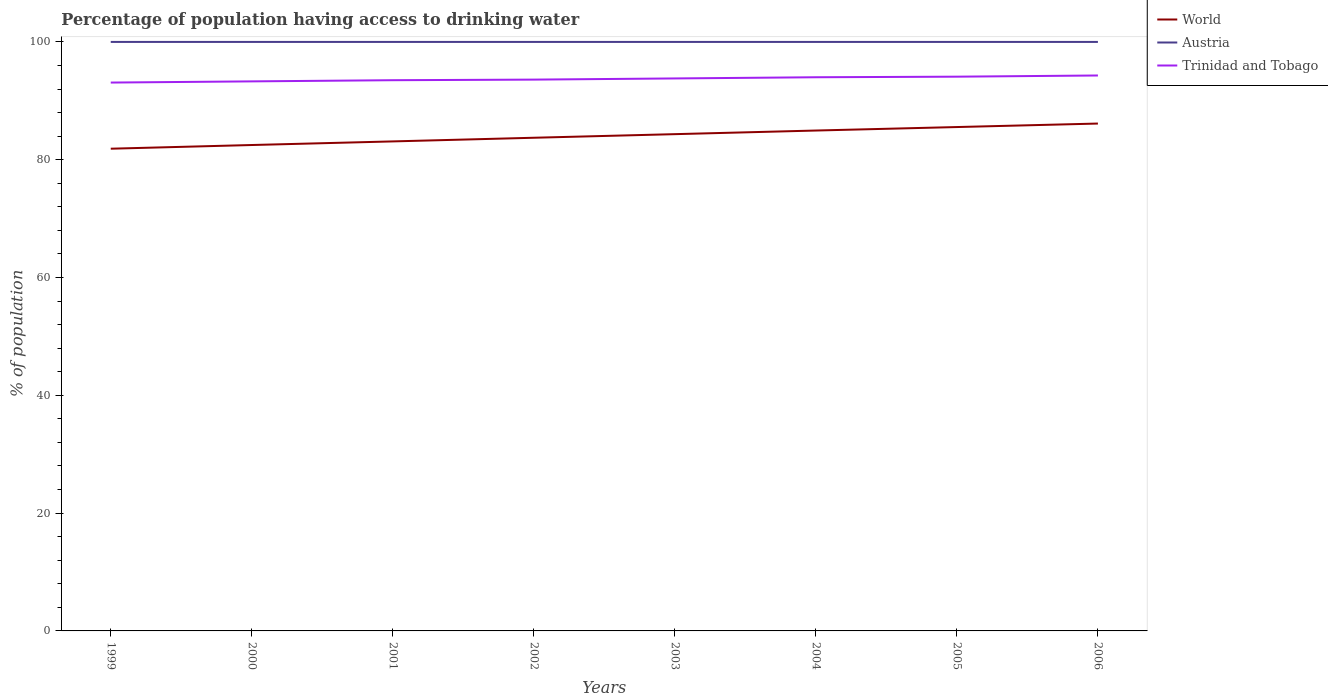How many different coloured lines are there?
Offer a very short reply. 3. Is the number of lines equal to the number of legend labels?
Ensure brevity in your answer.  Yes. Across all years, what is the maximum percentage of population having access to drinking water in Trinidad and Tobago?
Make the answer very short. 93.1. In which year was the percentage of population having access to drinking water in Trinidad and Tobago maximum?
Offer a very short reply. 1999. What is the total percentage of population having access to drinking water in World in the graph?
Your answer should be compact. -3.08. What is the difference between the highest and the second highest percentage of population having access to drinking water in Trinidad and Tobago?
Make the answer very short. 1.2. What is the difference between the highest and the lowest percentage of population having access to drinking water in World?
Provide a short and direct response. 4. How many years are there in the graph?
Offer a terse response. 8. Are the values on the major ticks of Y-axis written in scientific E-notation?
Make the answer very short. No. Does the graph contain grids?
Give a very brief answer. No. Where does the legend appear in the graph?
Your response must be concise. Top right. How are the legend labels stacked?
Your answer should be compact. Vertical. What is the title of the graph?
Offer a very short reply. Percentage of population having access to drinking water. Does "Belgium" appear as one of the legend labels in the graph?
Provide a succinct answer. No. What is the label or title of the X-axis?
Your answer should be very brief. Years. What is the label or title of the Y-axis?
Your answer should be very brief. % of population. What is the % of population of World in 1999?
Provide a succinct answer. 81.87. What is the % of population of Austria in 1999?
Keep it short and to the point. 100. What is the % of population of Trinidad and Tobago in 1999?
Your answer should be compact. 93.1. What is the % of population of World in 2000?
Ensure brevity in your answer.  82.5. What is the % of population in Trinidad and Tobago in 2000?
Give a very brief answer. 93.3. What is the % of population of World in 2001?
Offer a terse response. 83.11. What is the % of population of Austria in 2001?
Make the answer very short. 100. What is the % of population in Trinidad and Tobago in 2001?
Offer a very short reply. 93.5. What is the % of population in World in 2002?
Offer a very short reply. 83.73. What is the % of population of Austria in 2002?
Make the answer very short. 100. What is the % of population of Trinidad and Tobago in 2002?
Make the answer very short. 93.6. What is the % of population of World in 2003?
Your answer should be very brief. 84.34. What is the % of population in Austria in 2003?
Your response must be concise. 100. What is the % of population of Trinidad and Tobago in 2003?
Keep it short and to the point. 93.8. What is the % of population in World in 2004?
Provide a short and direct response. 84.95. What is the % of population in Austria in 2004?
Provide a succinct answer. 100. What is the % of population in Trinidad and Tobago in 2004?
Your answer should be very brief. 94. What is the % of population of World in 2005?
Keep it short and to the point. 85.55. What is the % of population of Trinidad and Tobago in 2005?
Ensure brevity in your answer.  94.1. What is the % of population in World in 2006?
Ensure brevity in your answer.  86.14. What is the % of population of Trinidad and Tobago in 2006?
Ensure brevity in your answer.  94.3. Across all years, what is the maximum % of population in World?
Make the answer very short. 86.14. Across all years, what is the maximum % of population in Trinidad and Tobago?
Keep it short and to the point. 94.3. Across all years, what is the minimum % of population in World?
Your answer should be compact. 81.87. Across all years, what is the minimum % of population in Trinidad and Tobago?
Your answer should be compact. 93.1. What is the total % of population of World in the graph?
Offer a very short reply. 672.19. What is the total % of population in Austria in the graph?
Your response must be concise. 800. What is the total % of population in Trinidad and Tobago in the graph?
Keep it short and to the point. 749.7. What is the difference between the % of population of World in 1999 and that in 2000?
Offer a terse response. -0.63. What is the difference between the % of population of Austria in 1999 and that in 2000?
Your answer should be compact. 0. What is the difference between the % of population of World in 1999 and that in 2001?
Ensure brevity in your answer.  -1.24. What is the difference between the % of population of World in 1999 and that in 2002?
Provide a succinct answer. -1.86. What is the difference between the % of population of Austria in 1999 and that in 2002?
Offer a terse response. 0. What is the difference between the % of population in Trinidad and Tobago in 1999 and that in 2002?
Offer a terse response. -0.5. What is the difference between the % of population in World in 1999 and that in 2003?
Provide a short and direct response. -2.47. What is the difference between the % of population of Austria in 1999 and that in 2003?
Give a very brief answer. 0. What is the difference between the % of population in World in 1999 and that in 2004?
Keep it short and to the point. -3.08. What is the difference between the % of population of Austria in 1999 and that in 2004?
Give a very brief answer. 0. What is the difference between the % of population in World in 1999 and that in 2005?
Provide a short and direct response. -3.68. What is the difference between the % of population of Austria in 1999 and that in 2005?
Provide a succinct answer. 0. What is the difference between the % of population in Trinidad and Tobago in 1999 and that in 2005?
Provide a short and direct response. -1. What is the difference between the % of population in World in 1999 and that in 2006?
Give a very brief answer. -4.27. What is the difference between the % of population in Austria in 1999 and that in 2006?
Provide a short and direct response. 0. What is the difference between the % of population of Trinidad and Tobago in 1999 and that in 2006?
Provide a succinct answer. -1.2. What is the difference between the % of population of World in 2000 and that in 2001?
Your answer should be very brief. -0.61. What is the difference between the % of population in Trinidad and Tobago in 2000 and that in 2001?
Your response must be concise. -0.2. What is the difference between the % of population of World in 2000 and that in 2002?
Offer a terse response. -1.23. What is the difference between the % of population of Austria in 2000 and that in 2002?
Your answer should be very brief. 0. What is the difference between the % of population in World in 2000 and that in 2003?
Provide a succinct answer. -1.84. What is the difference between the % of population of World in 2000 and that in 2004?
Ensure brevity in your answer.  -2.46. What is the difference between the % of population in Trinidad and Tobago in 2000 and that in 2004?
Keep it short and to the point. -0.7. What is the difference between the % of population of World in 2000 and that in 2005?
Offer a terse response. -3.05. What is the difference between the % of population of Trinidad and Tobago in 2000 and that in 2005?
Provide a short and direct response. -0.8. What is the difference between the % of population of World in 2000 and that in 2006?
Offer a terse response. -3.64. What is the difference between the % of population in Austria in 2000 and that in 2006?
Keep it short and to the point. 0. What is the difference between the % of population in World in 2001 and that in 2002?
Offer a terse response. -0.62. What is the difference between the % of population in Austria in 2001 and that in 2002?
Your answer should be very brief. 0. What is the difference between the % of population of World in 2001 and that in 2003?
Your response must be concise. -1.23. What is the difference between the % of population of Austria in 2001 and that in 2003?
Provide a short and direct response. 0. What is the difference between the % of population of Trinidad and Tobago in 2001 and that in 2003?
Offer a terse response. -0.3. What is the difference between the % of population in World in 2001 and that in 2004?
Make the answer very short. -1.85. What is the difference between the % of population in World in 2001 and that in 2005?
Provide a succinct answer. -2.44. What is the difference between the % of population of Trinidad and Tobago in 2001 and that in 2005?
Your response must be concise. -0.6. What is the difference between the % of population in World in 2001 and that in 2006?
Give a very brief answer. -3.03. What is the difference between the % of population in Trinidad and Tobago in 2001 and that in 2006?
Offer a terse response. -0.8. What is the difference between the % of population of World in 2002 and that in 2003?
Offer a terse response. -0.61. What is the difference between the % of population in Trinidad and Tobago in 2002 and that in 2003?
Provide a short and direct response. -0.2. What is the difference between the % of population in World in 2002 and that in 2004?
Make the answer very short. -1.22. What is the difference between the % of population of Trinidad and Tobago in 2002 and that in 2004?
Make the answer very short. -0.4. What is the difference between the % of population of World in 2002 and that in 2005?
Keep it short and to the point. -1.82. What is the difference between the % of population in Austria in 2002 and that in 2005?
Your answer should be very brief. 0. What is the difference between the % of population of World in 2002 and that in 2006?
Offer a terse response. -2.41. What is the difference between the % of population of Austria in 2002 and that in 2006?
Provide a short and direct response. 0. What is the difference between the % of population in World in 2003 and that in 2004?
Provide a succinct answer. -0.61. What is the difference between the % of population of World in 2003 and that in 2005?
Ensure brevity in your answer.  -1.21. What is the difference between the % of population in World in 2003 and that in 2006?
Your answer should be compact. -1.8. What is the difference between the % of population in Austria in 2003 and that in 2006?
Keep it short and to the point. 0. What is the difference between the % of population in Trinidad and Tobago in 2003 and that in 2006?
Ensure brevity in your answer.  -0.5. What is the difference between the % of population in World in 2004 and that in 2005?
Make the answer very short. -0.59. What is the difference between the % of population in World in 2004 and that in 2006?
Ensure brevity in your answer.  -1.19. What is the difference between the % of population of Trinidad and Tobago in 2004 and that in 2006?
Offer a very short reply. -0.3. What is the difference between the % of population in World in 2005 and that in 2006?
Provide a short and direct response. -0.59. What is the difference between the % of population of World in 1999 and the % of population of Austria in 2000?
Provide a succinct answer. -18.13. What is the difference between the % of population of World in 1999 and the % of population of Trinidad and Tobago in 2000?
Your answer should be very brief. -11.43. What is the difference between the % of population in World in 1999 and the % of population in Austria in 2001?
Your answer should be very brief. -18.13. What is the difference between the % of population of World in 1999 and the % of population of Trinidad and Tobago in 2001?
Keep it short and to the point. -11.63. What is the difference between the % of population in World in 1999 and the % of population in Austria in 2002?
Provide a succinct answer. -18.13. What is the difference between the % of population in World in 1999 and the % of population in Trinidad and Tobago in 2002?
Offer a very short reply. -11.73. What is the difference between the % of population in World in 1999 and the % of population in Austria in 2003?
Offer a very short reply. -18.13. What is the difference between the % of population of World in 1999 and the % of population of Trinidad and Tobago in 2003?
Give a very brief answer. -11.93. What is the difference between the % of population in Austria in 1999 and the % of population in Trinidad and Tobago in 2003?
Provide a short and direct response. 6.2. What is the difference between the % of population in World in 1999 and the % of population in Austria in 2004?
Your answer should be very brief. -18.13. What is the difference between the % of population in World in 1999 and the % of population in Trinidad and Tobago in 2004?
Ensure brevity in your answer.  -12.13. What is the difference between the % of population in World in 1999 and the % of population in Austria in 2005?
Your answer should be compact. -18.13. What is the difference between the % of population in World in 1999 and the % of population in Trinidad and Tobago in 2005?
Offer a very short reply. -12.23. What is the difference between the % of population of World in 1999 and the % of population of Austria in 2006?
Offer a very short reply. -18.13. What is the difference between the % of population in World in 1999 and the % of population in Trinidad and Tobago in 2006?
Give a very brief answer. -12.43. What is the difference between the % of population in World in 2000 and the % of population in Austria in 2001?
Offer a very short reply. -17.5. What is the difference between the % of population of World in 2000 and the % of population of Trinidad and Tobago in 2001?
Your answer should be very brief. -11. What is the difference between the % of population of World in 2000 and the % of population of Austria in 2002?
Offer a very short reply. -17.5. What is the difference between the % of population in World in 2000 and the % of population in Trinidad and Tobago in 2002?
Make the answer very short. -11.1. What is the difference between the % of population in Austria in 2000 and the % of population in Trinidad and Tobago in 2002?
Your response must be concise. 6.4. What is the difference between the % of population in World in 2000 and the % of population in Austria in 2003?
Your answer should be very brief. -17.5. What is the difference between the % of population in World in 2000 and the % of population in Trinidad and Tobago in 2003?
Offer a very short reply. -11.3. What is the difference between the % of population of World in 2000 and the % of population of Austria in 2004?
Make the answer very short. -17.5. What is the difference between the % of population of World in 2000 and the % of population of Trinidad and Tobago in 2004?
Keep it short and to the point. -11.5. What is the difference between the % of population in World in 2000 and the % of population in Austria in 2005?
Offer a terse response. -17.5. What is the difference between the % of population in World in 2000 and the % of population in Trinidad and Tobago in 2005?
Your answer should be very brief. -11.6. What is the difference between the % of population of World in 2000 and the % of population of Austria in 2006?
Give a very brief answer. -17.5. What is the difference between the % of population in World in 2000 and the % of population in Trinidad and Tobago in 2006?
Ensure brevity in your answer.  -11.8. What is the difference between the % of population in World in 2001 and the % of population in Austria in 2002?
Provide a succinct answer. -16.89. What is the difference between the % of population of World in 2001 and the % of population of Trinidad and Tobago in 2002?
Your answer should be very brief. -10.49. What is the difference between the % of population in World in 2001 and the % of population in Austria in 2003?
Keep it short and to the point. -16.89. What is the difference between the % of population of World in 2001 and the % of population of Trinidad and Tobago in 2003?
Offer a very short reply. -10.69. What is the difference between the % of population in Austria in 2001 and the % of population in Trinidad and Tobago in 2003?
Offer a terse response. 6.2. What is the difference between the % of population of World in 2001 and the % of population of Austria in 2004?
Provide a succinct answer. -16.89. What is the difference between the % of population of World in 2001 and the % of population of Trinidad and Tobago in 2004?
Give a very brief answer. -10.89. What is the difference between the % of population of Austria in 2001 and the % of population of Trinidad and Tobago in 2004?
Your response must be concise. 6. What is the difference between the % of population of World in 2001 and the % of population of Austria in 2005?
Provide a succinct answer. -16.89. What is the difference between the % of population in World in 2001 and the % of population in Trinidad and Tobago in 2005?
Provide a succinct answer. -10.99. What is the difference between the % of population of World in 2001 and the % of population of Austria in 2006?
Ensure brevity in your answer.  -16.89. What is the difference between the % of population of World in 2001 and the % of population of Trinidad and Tobago in 2006?
Offer a very short reply. -11.19. What is the difference between the % of population of Austria in 2001 and the % of population of Trinidad and Tobago in 2006?
Your response must be concise. 5.7. What is the difference between the % of population in World in 2002 and the % of population in Austria in 2003?
Provide a short and direct response. -16.27. What is the difference between the % of population in World in 2002 and the % of population in Trinidad and Tobago in 2003?
Your answer should be compact. -10.07. What is the difference between the % of population in World in 2002 and the % of population in Austria in 2004?
Provide a succinct answer. -16.27. What is the difference between the % of population in World in 2002 and the % of population in Trinidad and Tobago in 2004?
Your response must be concise. -10.27. What is the difference between the % of population in Austria in 2002 and the % of population in Trinidad and Tobago in 2004?
Ensure brevity in your answer.  6. What is the difference between the % of population in World in 2002 and the % of population in Austria in 2005?
Provide a short and direct response. -16.27. What is the difference between the % of population of World in 2002 and the % of population of Trinidad and Tobago in 2005?
Ensure brevity in your answer.  -10.37. What is the difference between the % of population of World in 2002 and the % of population of Austria in 2006?
Give a very brief answer. -16.27. What is the difference between the % of population in World in 2002 and the % of population in Trinidad and Tobago in 2006?
Offer a terse response. -10.57. What is the difference between the % of population in Austria in 2002 and the % of population in Trinidad and Tobago in 2006?
Your answer should be very brief. 5.7. What is the difference between the % of population of World in 2003 and the % of population of Austria in 2004?
Provide a short and direct response. -15.66. What is the difference between the % of population of World in 2003 and the % of population of Trinidad and Tobago in 2004?
Give a very brief answer. -9.66. What is the difference between the % of population in World in 2003 and the % of population in Austria in 2005?
Offer a very short reply. -15.66. What is the difference between the % of population in World in 2003 and the % of population in Trinidad and Tobago in 2005?
Your answer should be very brief. -9.76. What is the difference between the % of population in Austria in 2003 and the % of population in Trinidad and Tobago in 2005?
Keep it short and to the point. 5.9. What is the difference between the % of population of World in 2003 and the % of population of Austria in 2006?
Your answer should be very brief. -15.66. What is the difference between the % of population of World in 2003 and the % of population of Trinidad and Tobago in 2006?
Give a very brief answer. -9.96. What is the difference between the % of population of Austria in 2003 and the % of population of Trinidad and Tobago in 2006?
Ensure brevity in your answer.  5.7. What is the difference between the % of population in World in 2004 and the % of population in Austria in 2005?
Your answer should be very brief. -15.05. What is the difference between the % of population in World in 2004 and the % of population in Trinidad and Tobago in 2005?
Your answer should be compact. -9.15. What is the difference between the % of population of World in 2004 and the % of population of Austria in 2006?
Your answer should be very brief. -15.05. What is the difference between the % of population of World in 2004 and the % of population of Trinidad and Tobago in 2006?
Give a very brief answer. -9.35. What is the difference between the % of population in World in 2005 and the % of population in Austria in 2006?
Keep it short and to the point. -14.45. What is the difference between the % of population in World in 2005 and the % of population in Trinidad and Tobago in 2006?
Your answer should be compact. -8.75. What is the difference between the % of population in Austria in 2005 and the % of population in Trinidad and Tobago in 2006?
Offer a very short reply. 5.7. What is the average % of population of World per year?
Ensure brevity in your answer.  84.02. What is the average % of population in Austria per year?
Offer a terse response. 100. What is the average % of population of Trinidad and Tobago per year?
Your answer should be very brief. 93.71. In the year 1999, what is the difference between the % of population in World and % of population in Austria?
Give a very brief answer. -18.13. In the year 1999, what is the difference between the % of population in World and % of population in Trinidad and Tobago?
Ensure brevity in your answer.  -11.23. In the year 1999, what is the difference between the % of population of Austria and % of population of Trinidad and Tobago?
Keep it short and to the point. 6.9. In the year 2000, what is the difference between the % of population in World and % of population in Austria?
Your response must be concise. -17.5. In the year 2000, what is the difference between the % of population of World and % of population of Trinidad and Tobago?
Provide a short and direct response. -10.8. In the year 2001, what is the difference between the % of population in World and % of population in Austria?
Your answer should be compact. -16.89. In the year 2001, what is the difference between the % of population in World and % of population in Trinidad and Tobago?
Offer a very short reply. -10.39. In the year 2002, what is the difference between the % of population in World and % of population in Austria?
Provide a succinct answer. -16.27. In the year 2002, what is the difference between the % of population in World and % of population in Trinidad and Tobago?
Make the answer very short. -9.87. In the year 2002, what is the difference between the % of population of Austria and % of population of Trinidad and Tobago?
Keep it short and to the point. 6.4. In the year 2003, what is the difference between the % of population in World and % of population in Austria?
Provide a succinct answer. -15.66. In the year 2003, what is the difference between the % of population in World and % of population in Trinidad and Tobago?
Provide a short and direct response. -9.46. In the year 2003, what is the difference between the % of population of Austria and % of population of Trinidad and Tobago?
Give a very brief answer. 6.2. In the year 2004, what is the difference between the % of population in World and % of population in Austria?
Provide a short and direct response. -15.05. In the year 2004, what is the difference between the % of population in World and % of population in Trinidad and Tobago?
Offer a very short reply. -9.05. In the year 2004, what is the difference between the % of population of Austria and % of population of Trinidad and Tobago?
Your answer should be very brief. 6. In the year 2005, what is the difference between the % of population in World and % of population in Austria?
Make the answer very short. -14.45. In the year 2005, what is the difference between the % of population of World and % of population of Trinidad and Tobago?
Offer a very short reply. -8.55. In the year 2005, what is the difference between the % of population in Austria and % of population in Trinidad and Tobago?
Offer a terse response. 5.9. In the year 2006, what is the difference between the % of population of World and % of population of Austria?
Your response must be concise. -13.86. In the year 2006, what is the difference between the % of population in World and % of population in Trinidad and Tobago?
Keep it short and to the point. -8.16. In the year 2006, what is the difference between the % of population in Austria and % of population in Trinidad and Tobago?
Your answer should be very brief. 5.7. What is the ratio of the % of population in Trinidad and Tobago in 1999 to that in 2000?
Provide a succinct answer. 1. What is the ratio of the % of population in World in 1999 to that in 2001?
Provide a short and direct response. 0.99. What is the ratio of the % of population of Austria in 1999 to that in 2001?
Provide a succinct answer. 1. What is the ratio of the % of population in Trinidad and Tobago in 1999 to that in 2001?
Ensure brevity in your answer.  1. What is the ratio of the % of population in World in 1999 to that in 2002?
Provide a succinct answer. 0.98. What is the ratio of the % of population of Trinidad and Tobago in 1999 to that in 2002?
Provide a short and direct response. 0.99. What is the ratio of the % of population in World in 1999 to that in 2003?
Provide a short and direct response. 0.97. What is the ratio of the % of population of Austria in 1999 to that in 2003?
Provide a succinct answer. 1. What is the ratio of the % of population of World in 1999 to that in 2004?
Offer a very short reply. 0.96. What is the ratio of the % of population in Austria in 1999 to that in 2004?
Offer a very short reply. 1. What is the ratio of the % of population in Trinidad and Tobago in 1999 to that in 2004?
Your answer should be compact. 0.99. What is the ratio of the % of population in Austria in 1999 to that in 2005?
Keep it short and to the point. 1. What is the ratio of the % of population in World in 1999 to that in 2006?
Provide a short and direct response. 0.95. What is the ratio of the % of population in Austria in 1999 to that in 2006?
Make the answer very short. 1. What is the ratio of the % of population of Trinidad and Tobago in 1999 to that in 2006?
Your answer should be very brief. 0.99. What is the ratio of the % of population in World in 2000 to that in 2001?
Offer a very short reply. 0.99. What is the ratio of the % of population in Austria in 2000 to that in 2001?
Your response must be concise. 1. What is the ratio of the % of population of Trinidad and Tobago in 2000 to that in 2002?
Provide a short and direct response. 1. What is the ratio of the % of population of World in 2000 to that in 2003?
Your answer should be compact. 0.98. What is the ratio of the % of population of Trinidad and Tobago in 2000 to that in 2003?
Your answer should be compact. 0.99. What is the ratio of the % of population in World in 2000 to that in 2004?
Provide a short and direct response. 0.97. What is the ratio of the % of population in Austria in 2000 to that in 2005?
Your answer should be very brief. 1. What is the ratio of the % of population of Trinidad and Tobago in 2000 to that in 2005?
Provide a succinct answer. 0.99. What is the ratio of the % of population of World in 2000 to that in 2006?
Offer a very short reply. 0.96. What is the ratio of the % of population of Austria in 2000 to that in 2006?
Provide a short and direct response. 1. What is the ratio of the % of population in Trinidad and Tobago in 2000 to that in 2006?
Keep it short and to the point. 0.99. What is the ratio of the % of population of Trinidad and Tobago in 2001 to that in 2002?
Offer a very short reply. 1. What is the ratio of the % of population in World in 2001 to that in 2003?
Your answer should be very brief. 0.99. What is the ratio of the % of population of World in 2001 to that in 2004?
Provide a succinct answer. 0.98. What is the ratio of the % of population of Austria in 2001 to that in 2004?
Make the answer very short. 1. What is the ratio of the % of population in Trinidad and Tobago in 2001 to that in 2004?
Offer a very short reply. 0.99. What is the ratio of the % of population in World in 2001 to that in 2005?
Provide a succinct answer. 0.97. What is the ratio of the % of population of Austria in 2001 to that in 2005?
Your answer should be very brief. 1. What is the ratio of the % of population of Trinidad and Tobago in 2001 to that in 2005?
Provide a succinct answer. 0.99. What is the ratio of the % of population in World in 2001 to that in 2006?
Your answer should be compact. 0.96. What is the ratio of the % of population in Austria in 2001 to that in 2006?
Your response must be concise. 1. What is the ratio of the % of population of Trinidad and Tobago in 2001 to that in 2006?
Provide a succinct answer. 0.99. What is the ratio of the % of population of Austria in 2002 to that in 2003?
Give a very brief answer. 1. What is the ratio of the % of population in World in 2002 to that in 2004?
Offer a terse response. 0.99. What is the ratio of the % of population of World in 2002 to that in 2005?
Provide a short and direct response. 0.98. What is the ratio of the % of population in Austria in 2002 to that in 2005?
Your answer should be very brief. 1. What is the ratio of the % of population of Austria in 2002 to that in 2006?
Make the answer very short. 1. What is the ratio of the % of population of Austria in 2003 to that in 2004?
Make the answer very short. 1. What is the ratio of the % of population of World in 2003 to that in 2005?
Make the answer very short. 0.99. What is the ratio of the % of population in World in 2003 to that in 2006?
Offer a terse response. 0.98. What is the ratio of the % of population of Trinidad and Tobago in 2004 to that in 2005?
Make the answer very short. 1. What is the ratio of the % of population of World in 2004 to that in 2006?
Provide a succinct answer. 0.99. What is the ratio of the % of population in Austria in 2004 to that in 2006?
Keep it short and to the point. 1. What is the ratio of the % of population in World in 2005 to that in 2006?
Your answer should be compact. 0.99. What is the difference between the highest and the second highest % of population of World?
Give a very brief answer. 0.59. What is the difference between the highest and the second highest % of population in Austria?
Keep it short and to the point. 0. What is the difference between the highest and the second highest % of population in Trinidad and Tobago?
Your answer should be very brief. 0.2. What is the difference between the highest and the lowest % of population of World?
Your answer should be very brief. 4.27. What is the difference between the highest and the lowest % of population of Austria?
Offer a terse response. 0. 